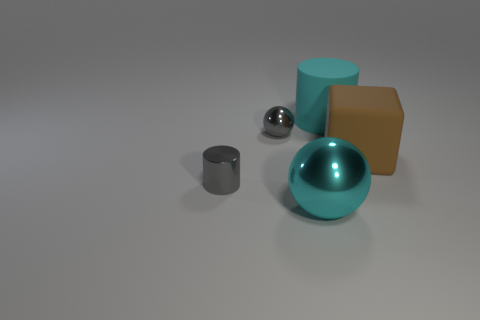Add 4 large green things. How many objects exist? 9 Subtract all spheres. How many objects are left? 3 Add 2 tiny metallic cylinders. How many tiny metallic cylinders are left? 3 Add 2 gray rubber spheres. How many gray rubber spheres exist? 2 Subtract 1 gray cylinders. How many objects are left? 4 Subtract all gray shiny balls. Subtract all big green objects. How many objects are left? 4 